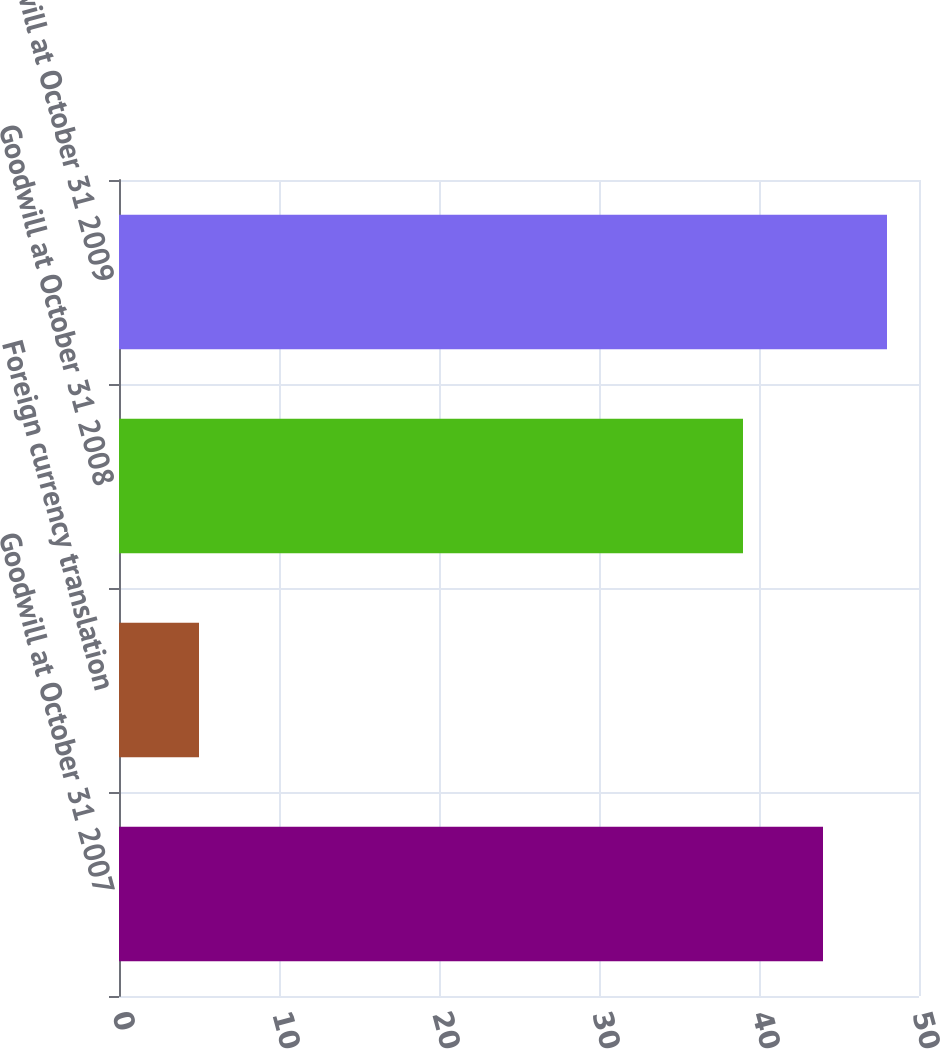Convert chart to OTSL. <chart><loc_0><loc_0><loc_500><loc_500><bar_chart><fcel>Goodwill at October 31 2007<fcel>Foreign currency translation<fcel>Goodwill at October 31 2008<fcel>Goodwill at October 31 2009<nl><fcel>44<fcel>5<fcel>39<fcel>48<nl></chart> 